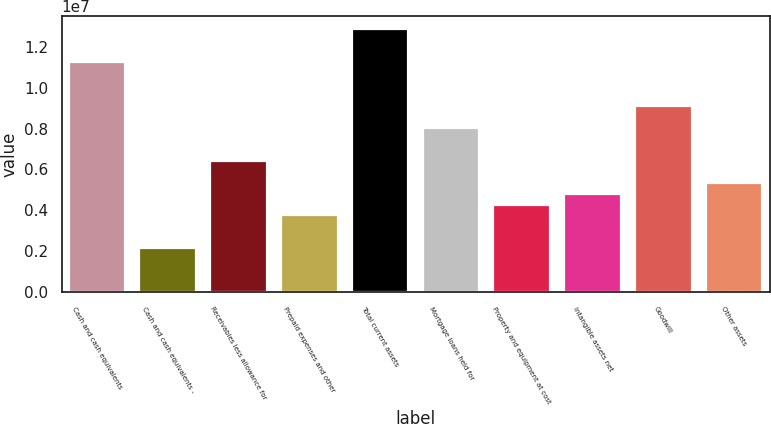Convert chart to OTSL. <chart><loc_0><loc_0><loc_500><loc_500><bar_chart><fcel>Cash and cash equivalents<fcel>Cash and cash equivalents -<fcel>Receivables less allowance for<fcel>Prepaid expenses and other<fcel>Total current assets<fcel>Mortgage loans held for<fcel>Property and equipment at cost<fcel>Intangible assets net<fcel>Goodwill<fcel>Other assets<nl><fcel>1.12505e+07<fcel>2.14655e+06<fcel>6.43078e+06<fcel>3.75314e+06<fcel>1.28571e+07<fcel>8.03736e+06<fcel>4.28867e+06<fcel>4.82419e+06<fcel>9.10842e+06<fcel>5.35972e+06<nl></chart> 